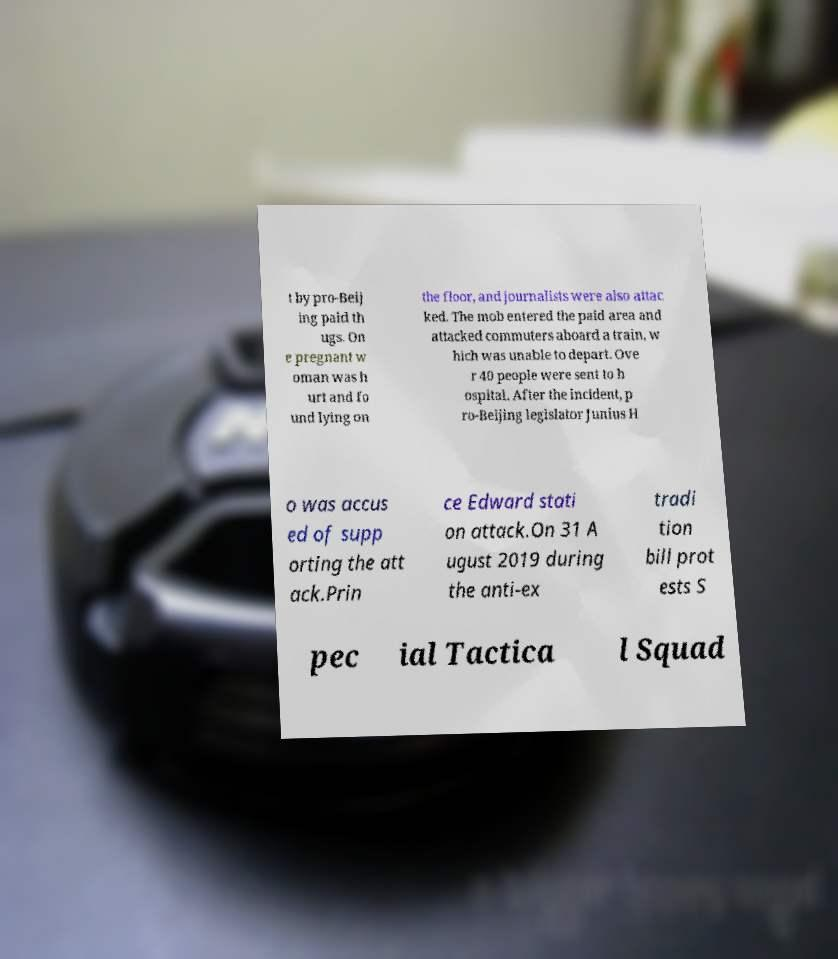What messages or text are displayed in this image? I need them in a readable, typed format. t by pro-Beij ing paid th ugs. On e pregnant w oman was h urt and fo und lying on the floor, and journalists were also attac ked. The mob entered the paid area and attacked commuters aboard a train, w hich was unable to depart. Ove r 40 people were sent to h ospital. After the incident, p ro-Beijing legislator Junius H o was accus ed of supp orting the att ack.Prin ce Edward stati on attack.On 31 A ugust 2019 during the anti-ex tradi tion bill prot ests S pec ial Tactica l Squad 